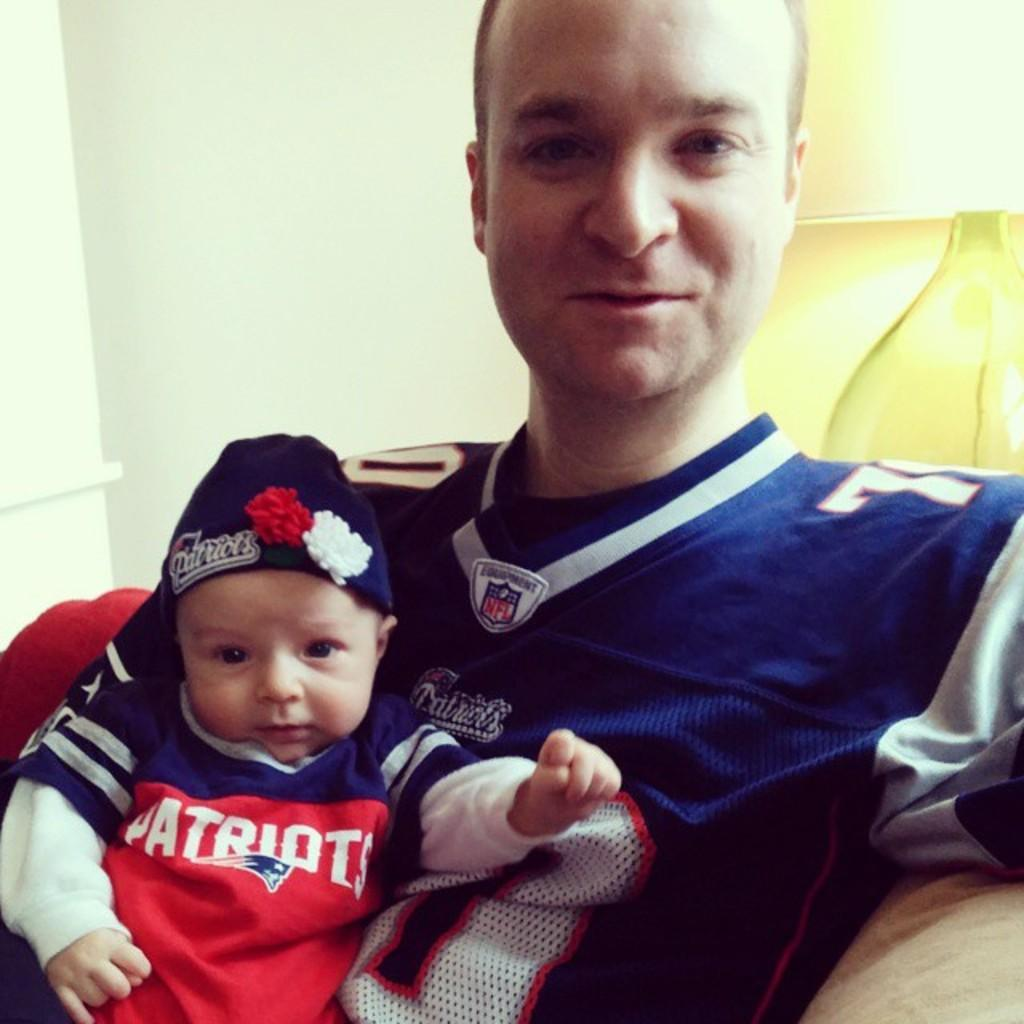Provide a one-sentence caption for the provided image. a person that has Patriots on their shirt posing with their dad. 